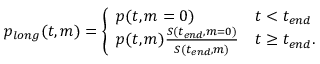Convert formula to latex. <formula><loc_0><loc_0><loc_500><loc_500>\begin{array} { r } { p _ { l o n g } ( t , m ) = \left \{ \begin{array} { l l } { p ( t , m = 0 ) } & { t < t _ { e n d } } \\ { p ( t , m ) \frac { S ( t _ { e n d } , m = 0 ) } { S ( t _ { e n d } , m ) } } & { t \geq t _ { e n d } . } \end{array} } \end{array}</formula> 